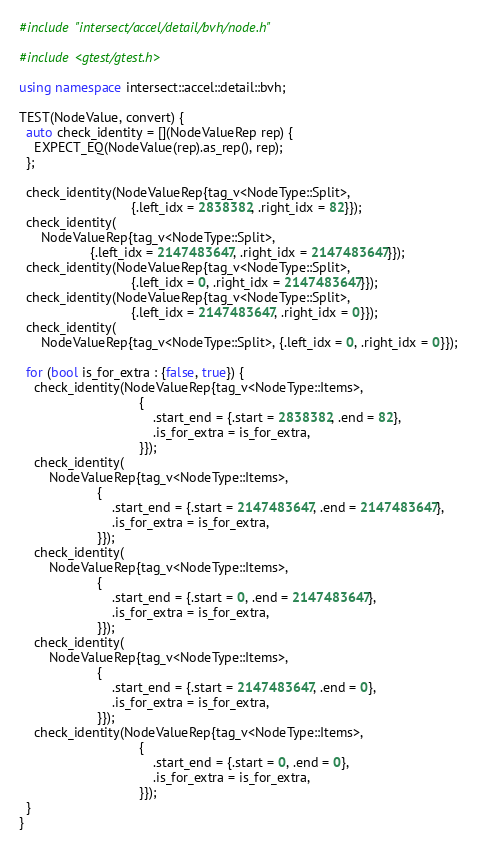<code> <loc_0><loc_0><loc_500><loc_500><_C++_>#include "intersect/accel/detail/bvh/node.h"

#include <gtest/gtest.h>

using namespace intersect::accel::detail::bvh;

TEST(NodeValue, convert) {
  auto check_identity = [](NodeValueRep rep) {
    EXPECT_EQ(NodeValue(rep).as_rep(), rep);
  };

  check_identity(NodeValueRep{tag_v<NodeType::Split>,
                              {.left_idx = 2838382, .right_idx = 82}});
  check_identity(
      NodeValueRep{tag_v<NodeType::Split>,
                   {.left_idx = 2147483647, .right_idx = 2147483647}});
  check_identity(NodeValueRep{tag_v<NodeType::Split>,
                              {.left_idx = 0, .right_idx = 2147483647}});
  check_identity(NodeValueRep{tag_v<NodeType::Split>,
                              {.left_idx = 2147483647, .right_idx = 0}});
  check_identity(
      NodeValueRep{tag_v<NodeType::Split>, {.left_idx = 0, .right_idx = 0}});

  for (bool is_for_extra : {false, true}) {
    check_identity(NodeValueRep{tag_v<NodeType::Items>,
                                {
                                    .start_end = {.start = 2838382, .end = 82},
                                    .is_for_extra = is_for_extra,
                                }});
    check_identity(
        NodeValueRep{tag_v<NodeType::Items>,
                     {
                         .start_end = {.start = 2147483647, .end = 2147483647},
                         .is_for_extra = is_for_extra,
                     }});
    check_identity(
        NodeValueRep{tag_v<NodeType::Items>,
                     {
                         .start_end = {.start = 0, .end = 2147483647},
                         .is_for_extra = is_for_extra,
                     }});
    check_identity(
        NodeValueRep{tag_v<NodeType::Items>,
                     {
                         .start_end = {.start = 2147483647, .end = 0},
                         .is_for_extra = is_for_extra,
                     }});
    check_identity(NodeValueRep{tag_v<NodeType::Items>,
                                {
                                    .start_end = {.start = 0, .end = 0},
                                    .is_for_extra = is_for_extra,
                                }});
  }
}
</code> 